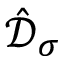<formula> <loc_0><loc_0><loc_500><loc_500>\hat { \mathcal { D } } _ { \sigma }</formula> 